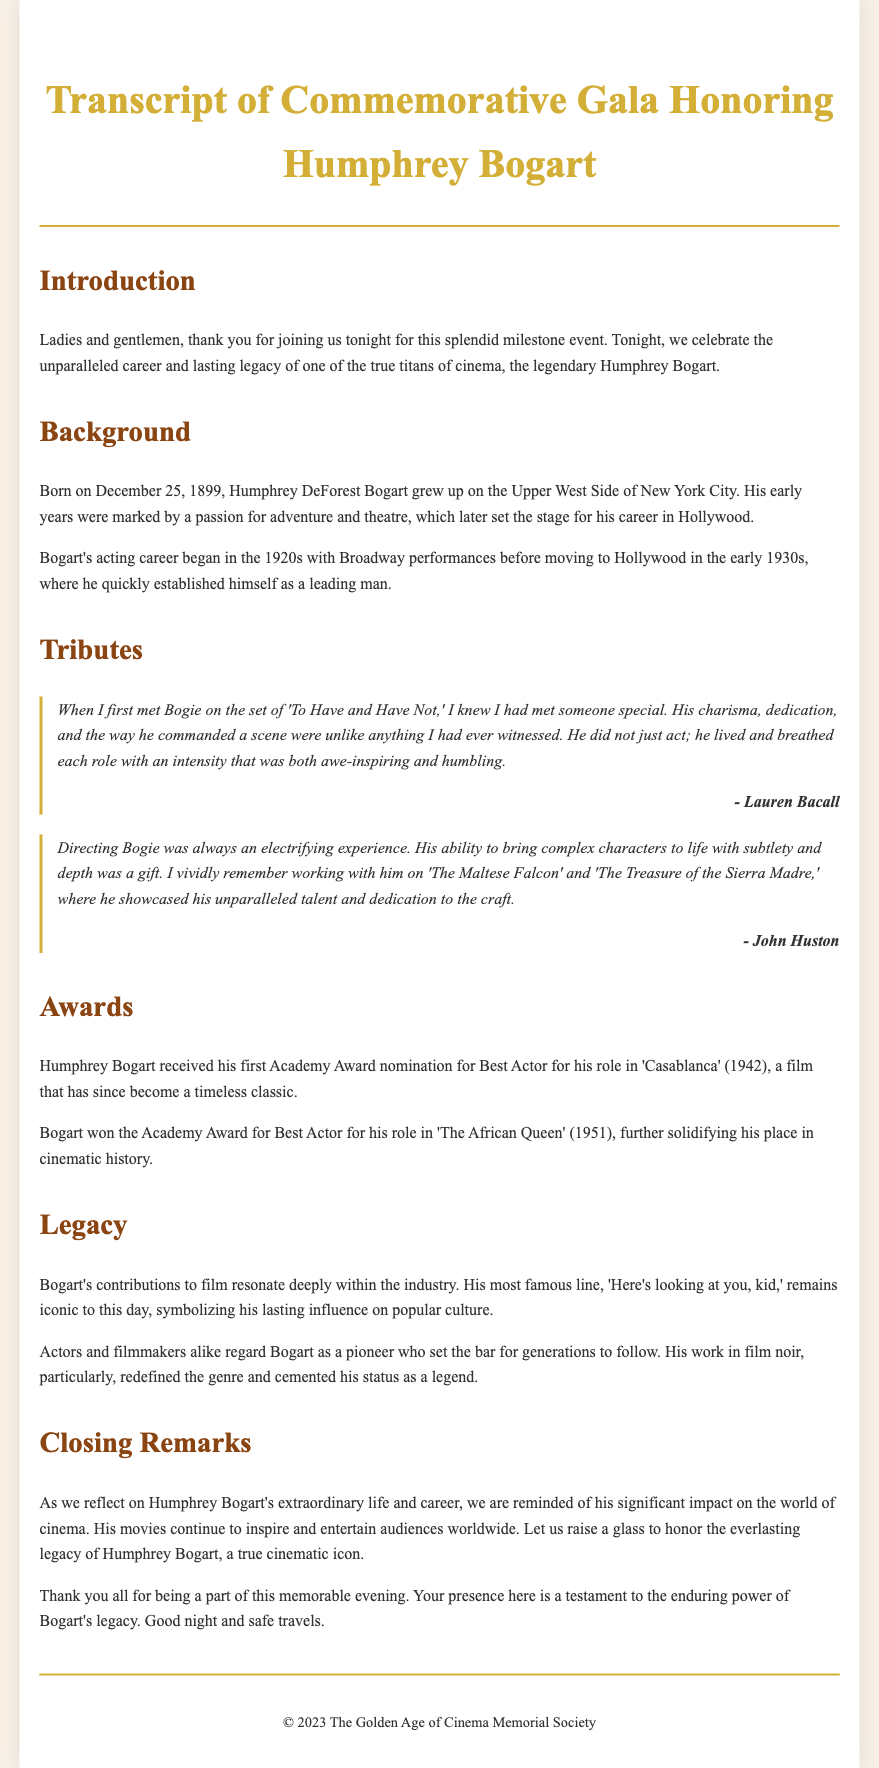What is the full name of the legendary actor being honored? The document states the actor's full name as Humphrey DeForest Bogart.
Answer: Humphrey DeForest Bogart What was the date of birth of Humphrey Bogart? According to the background section of the document, he was born on December 25, 1899.
Answer: December 25, 1899 Who provided a tribute about working with Bogart on 'To Have and Have Not'? The document attributes the quote about Bogart on 'To Have and Have Not' to Lauren Bacall.
Answer: Lauren Bacall What was the first Academy Award nomination for Bogart? The document mentions that he received his first nomination for Best Actor for his role in 'Casablanca' (1942).
Answer: 'Casablanca' What year did Bogart win the Academy Award for Best Actor? The document states he won the Academy Award for Best Actor for 'The African Queen' in 1951.
Answer: 1951 How is Bogart's most famous line described in the document? The document indicates that his most famous line, "Here's looking at you, kid," remains iconic.
Answer: Iconic What genre did Bogart help redefine according to the legacy section? The document specifies that he had a significant impact on the film noir genre.
Answer: Film noir What is mentioned as a testament to Bogart's legacy during the closing remarks? The closing remarks indicate that the audience's presence is a testament to the enduring power of Bogart's legacy.
Answer: Enduring power of Bogart's legacy 